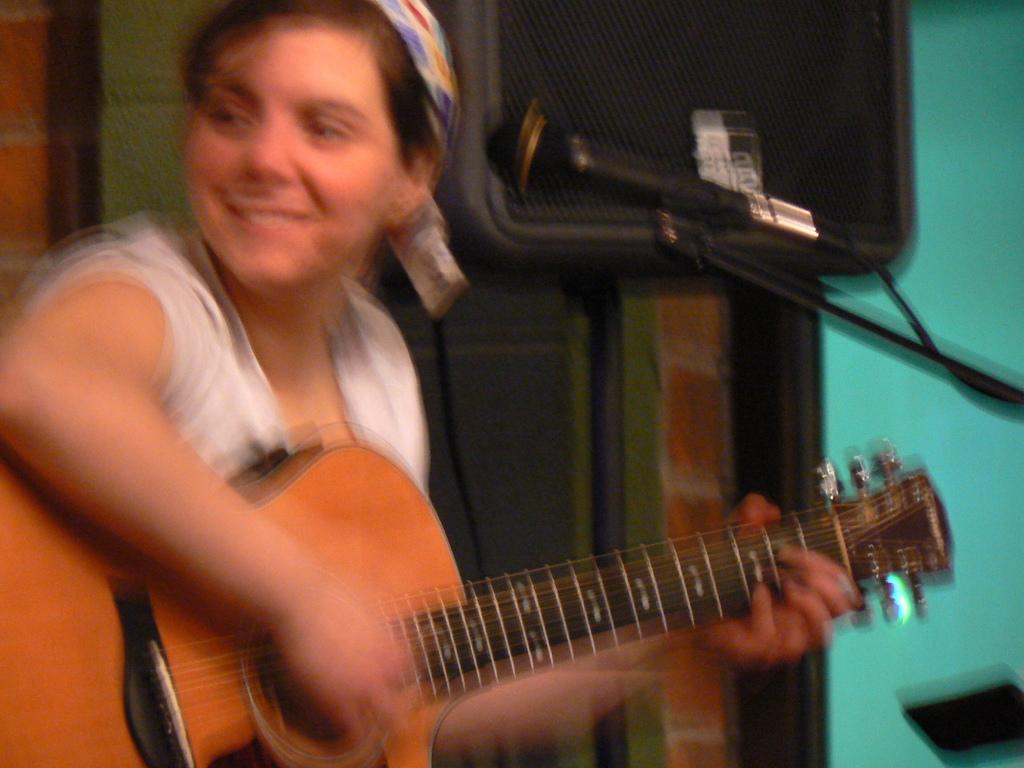Who is the main subject in the image? There is a woman in the image. What is the woman doing in the image? The woman is playing a guitar. What object is in front of the woman? There is a microphone in front of the woman. What type of mark can be seen on the bedroom wall in the image? There is no bedroom or mark present in the image; it features a woman playing a guitar with a microphone in front of her. 